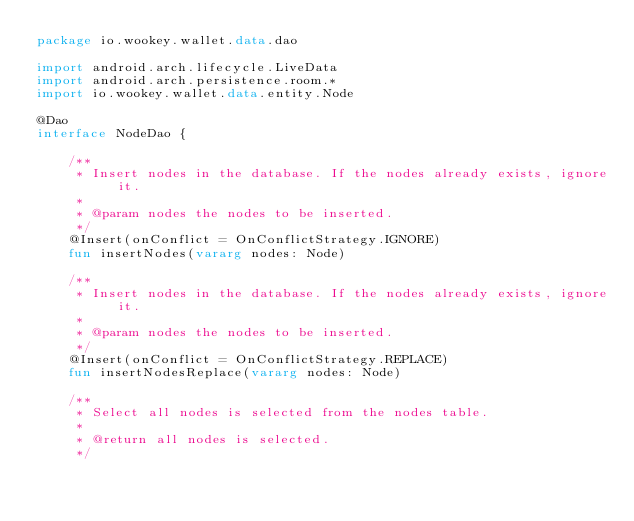<code> <loc_0><loc_0><loc_500><loc_500><_Kotlin_>package io.wookey.wallet.data.dao

import android.arch.lifecycle.LiveData
import android.arch.persistence.room.*
import io.wookey.wallet.data.entity.Node

@Dao
interface NodeDao {

    /**
     * Insert nodes in the database. If the nodes already exists, ignore it.
     *
     * @param nodes the nodes to be inserted.
     */
    @Insert(onConflict = OnConflictStrategy.IGNORE)
    fun insertNodes(vararg nodes: Node)

    /**
     * Insert nodes in the database. If the nodes already exists, ignore it.
     *
     * @param nodes the nodes to be inserted.
     */
    @Insert(onConflict = OnConflictStrategy.REPLACE)
    fun insertNodesReplace(vararg nodes: Node)

    /**
     * Select all nodes is selected from the nodes table.
     *
     * @return all nodes is selected.
     */</code> 